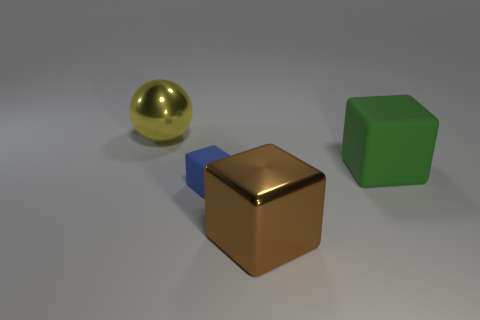What can you tell me about the surface the objects are resting on? The objects are resting on a smooth, matte surface that gives the impression of a solid, even foundation. Its muted color suggests it may be something like brushed steel or a stone material, which contrasts with the shinier textures of the objects above it. 